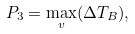Convert formula to latex. <formula><loc_0><loc_0><loc_500><loc_500>P _ { 3 } = \max _ { v } ( \Delta T _ { B } ) ,</formula> 